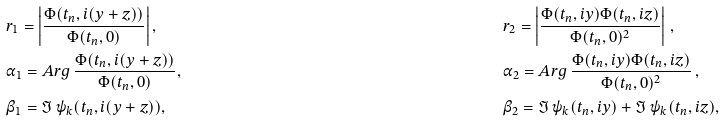Convert formula to latex. <formula><loc_0><loc_0><loc_500><loc_500>& r _ { 1 } = \left | \frac { \Phi ( t _ { n } , i ( y + z ) ) } { \Phi ( t _ { n } , 0 ) } \right | , & \quad & r _ { 2 } = \left | \frac { \Phi ( t _ { n } , i y ) \Phi ( t _ { n } , i z ) } { \Phi ( t _ { n } , 0 ) ^ { 2 } } \right | \, , \\ & \alpha _ { 1 } = A r g \, \frac { \Phi ( t _ { n } , i ( y + z ) ) } { \Phi ( t _ { n } , 0 ) } , & \quad & \alpha _ { 2 } = A r g \, \frac { \Phi ( t _ { n } , i y ) \Phi ( t _ { n } , i z ) } { \Phi ( t _ { n } , 0 ) ^ { 2 } } \, , \\ & \beta _ { 1 } = \Im \, \psi _ { k } ( t _ { n } , i ( y + z ) ) , & \quad & \beta _ { 2 } = \Im \, \psi _ { k } ( t _ { n } , i y ) + \Im \, \psi _ { k } ( t _ { n } , i z ) ,</formula> 